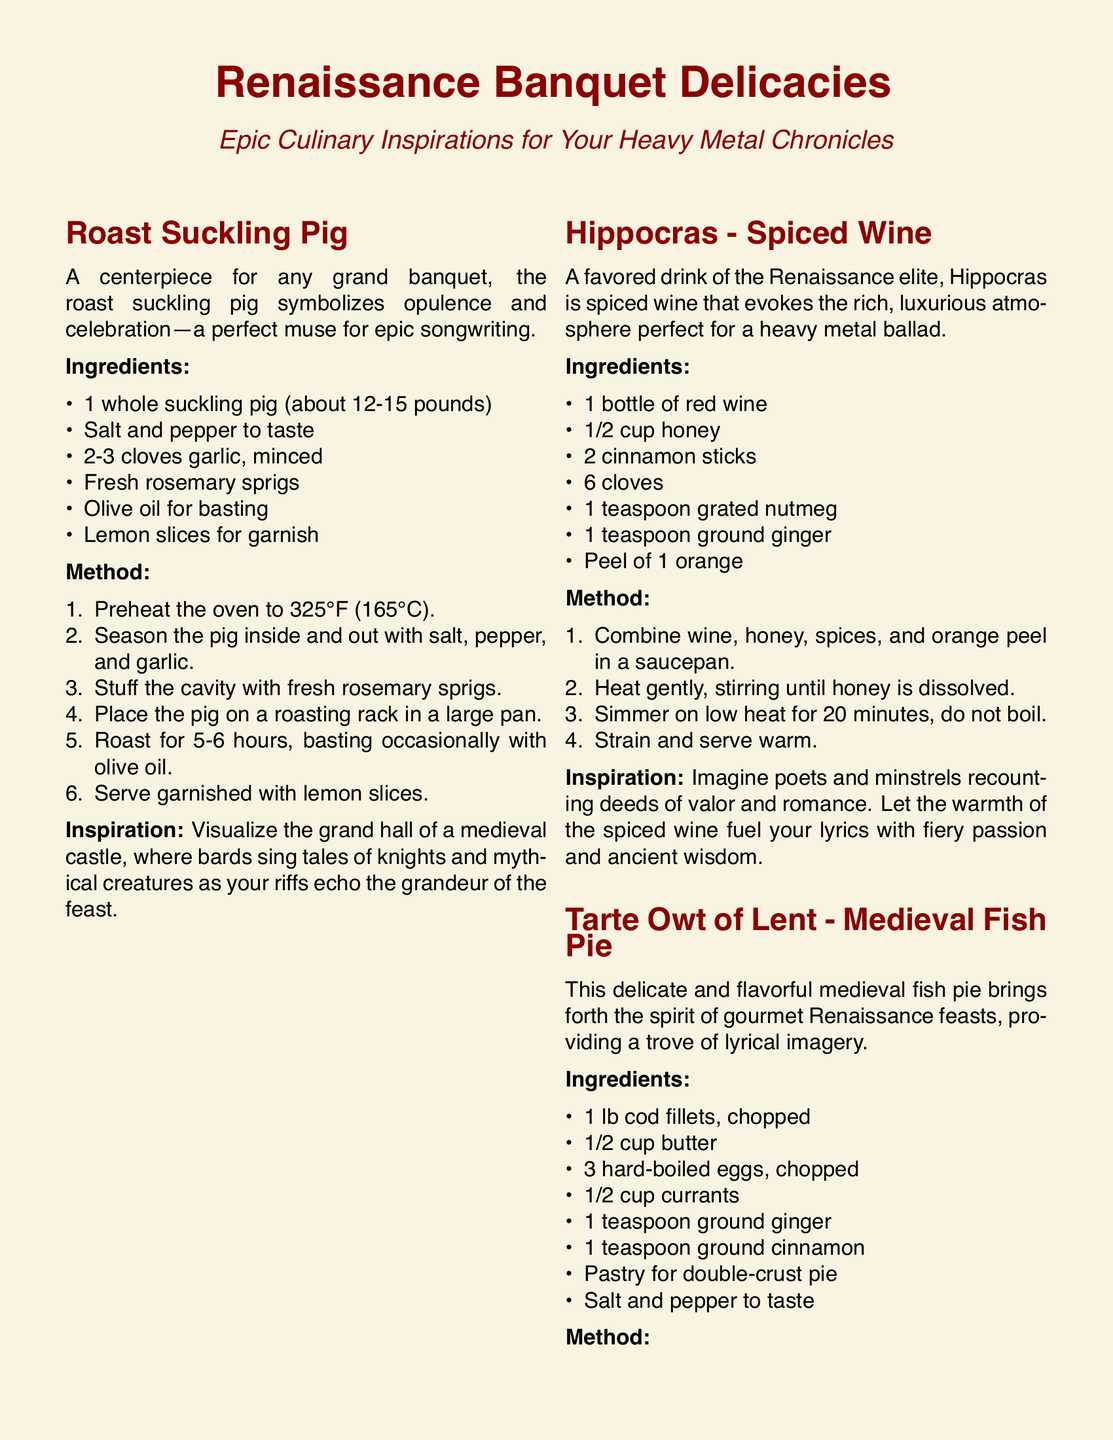What is the main ingredient of the roast suckling pig? The main ingredient of the roast suckling pig is a whole suckling pig.
Answer: whole suckling pig How long should the roast suckling pig be cooked? The roast suckling pig should be roasted for 5-6 hours.
Answer: 5-6 hours What sweetener is used in the Hippocras recipe? The Hippocras recipe uses honey as a sweetener.
Answer: honey What type of fish is used in the Tarte Owt of Lent? The Tarte Owt of Lent uses cod fillets as the type of fish.
Answer: cod fillets Which ingredient is paired with ground ginger in Hippocras? In Hippocras, ground ginger is paired with nutmeg.
Answer: nutmeg What is the baking temperature for the Tarte Owt of Lent? The baking temperature for the Tarte Owt of Lent is 375°F.
Answer: 375°F What type of atmosphere does Hippocras evoke? Hippocras evokes a rich, luxurious atmosphere.
Answer: rich, luxurious atmosphere What is the main theme of the document? The main theme of the document is Epic Culinary Inspirations for Your Heavy Metal Chronicles.
Answer: Epic Culinary Inspirations for Your Heavy Metal Chronicles What is the cooking method used for the fish in Tarte Owt of Lent? The cooking method used for the fish in Tarte Owt of Lent is sautéed.
Answer: sautéed 